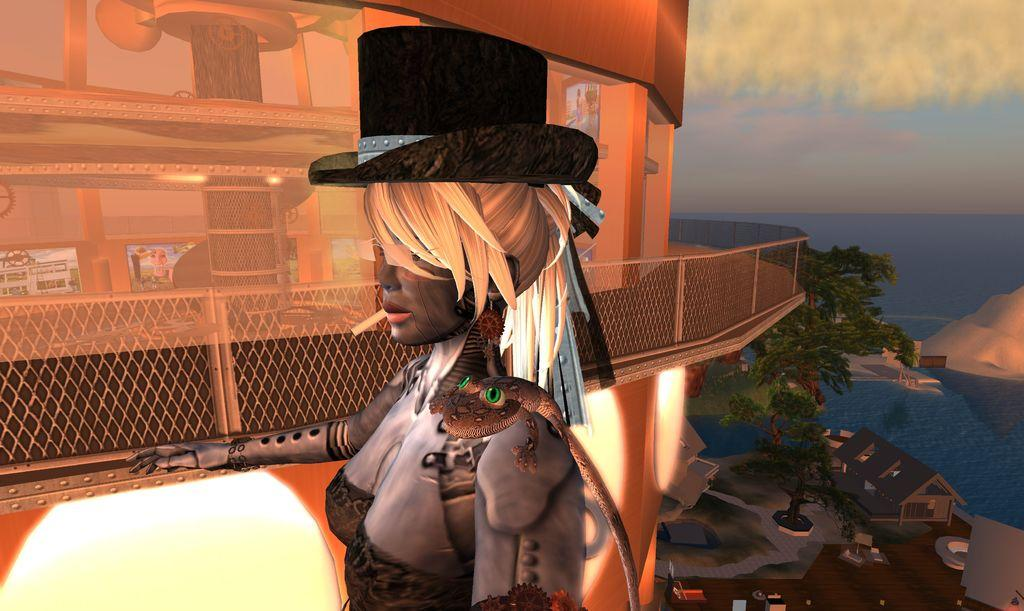Who is present in the image? There is a lady in the image. What is on the lady? There is a lizard on the lady. What can be seen in the background of the image? There is a building, trees, houses, a sea, and the sky visible in the background of the image. What type of arch can be seen in the image? There is no arch present in the image. How does the lady use her arm to pull something in the image? The lady is not shown using her arm to pull anything in the image. 